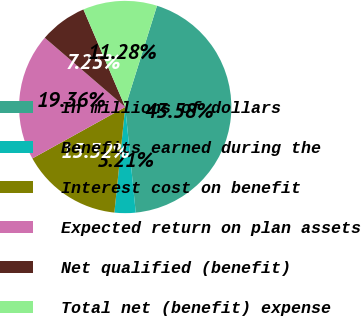Convert chart to OTSL. <chart><loc_0><loc_0><loc_500><loc_500><pie_chart><fcel>In millions of dollars<fcel>Benefits earned during the<fcel>Interest cost on benefit<fcel>Expected return on plan assets<fcel>Net qualified (benefit)<fcel>Total net (benefit) expense<nl><fcel>43.58%<fcel>3.21%<fcel>15.32%<fcel>19.36%<fcel>7.25%<fcel>11.28%<nl></chart> 